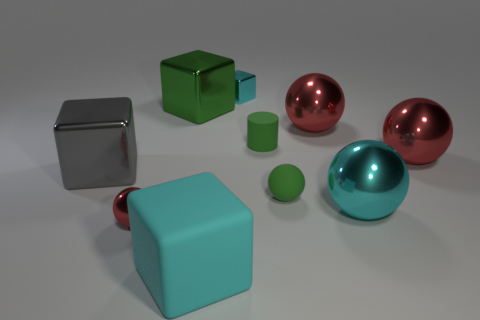Subtract all red spheres. How many were subtracted if there are1red spheres left? 2 Subtract all blue cubes. How many red spheres are left? 3 Subtract all green balls. How many balls are left? 4 Subtract all small rubber balls. How many balls are left? 4 Subtract all yellow balls. Subtract all red blocks. How many balls are left? 5 Subtract all cylinders. How many objects are left? 9 Add 6 small cyan objects. How many small cyan objects are left? 7 Add 8 purple metallic balls. How many purple metallic balls exist? 8 Subtract 0 red cubes. How many objects are left? 10 Subtract all small gray matte objects. Subtract all big balls. How many objects are left? 7 